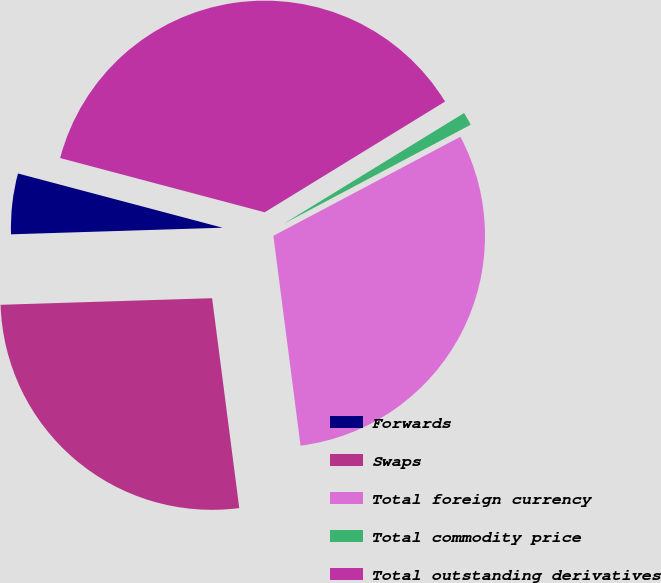<chart> <loc_0><loc_0><loc_500><loc_500><pie_chart><fcel>Forwards<fcel>Swaps<fcel>Total foreign currency<fcel>Total commodity price<fcel>Total outstanding derivatives<nl><fcel>4.62%<fcel>26.55%<fcel>30.7%<fcel>1.01%<fcel>37.11%<nl></chart> 